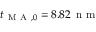Convert formula to latex. <formula><loc_0><loc_0><loc_500><loc_500>t _ { M A , 0 } = 8 . 8 2 \, n m</formula> 